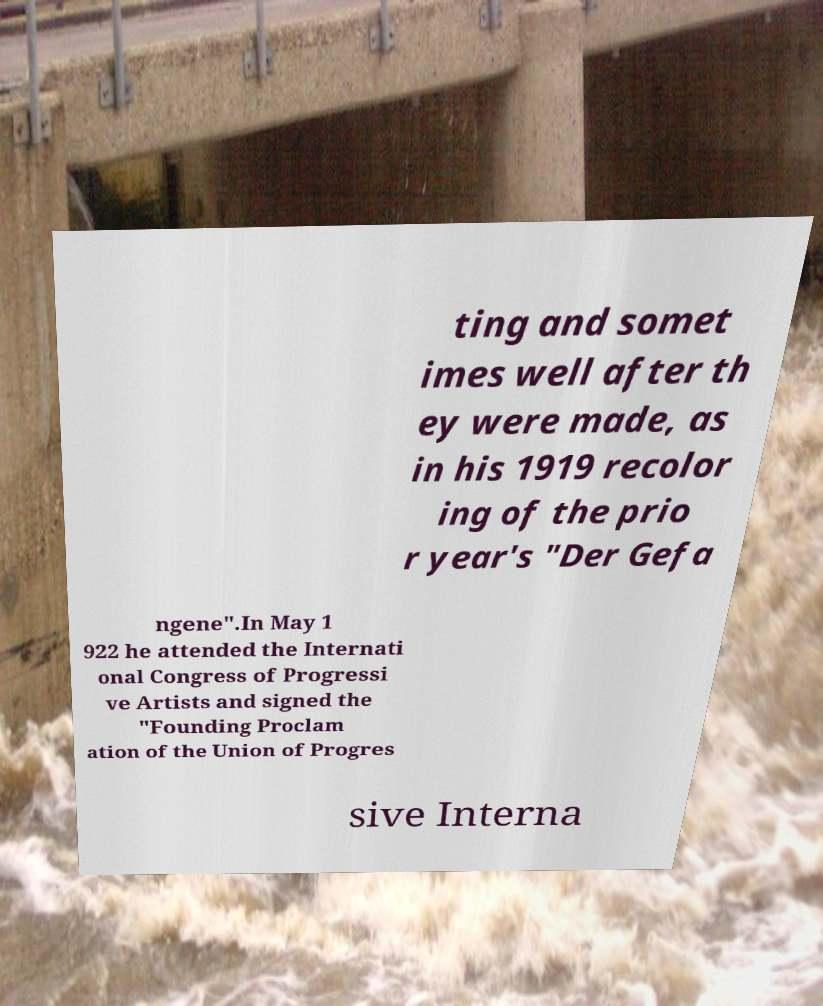Please identify and transcribe the text found in this image. ting and somet imes well after th ey were made, as in his 1919 recolor ing of the prio r year's "Der Gefa ngene".In May 1 922 he attended the Internati onal Congress of Progressi ve Artists and signed the "Founding Proclam ation of the Union of Progres sive Interna 